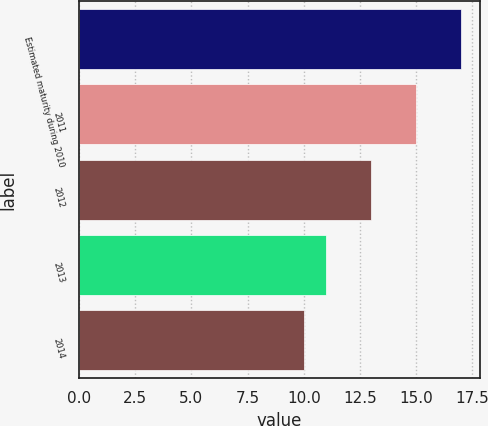<chart> <loc_0><loc_0><loc_500><loc_500><bar_chart><fcel>Estimated maturity during 2010<fcel>2011<fcel>2012<fcel>2013<fcel>2014<nl><fcel>17<fcel>15<fcel>13<fcel>11<fcel>10<nl></chart> 